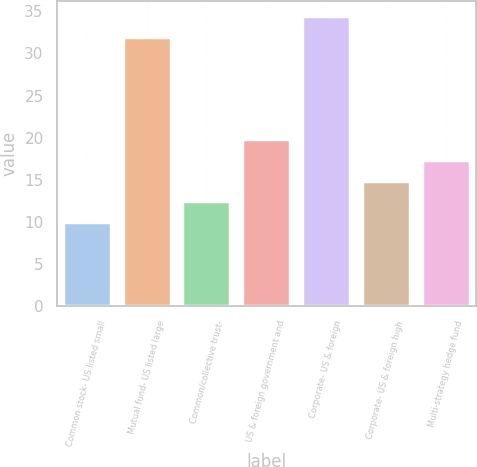<chart> <loc_0><loc_0><loc_500><loc_500><bar_chart><fcel>Common stock- US listed small<fcel>Mutual fund- US listed large<fcel>Common/collective trust-<fcel>US & foreign government and<fcel>Corporate- US & foreign<fcel>Corporate- US & foreign high<fcel>Multi-strategy hedge fund<nl><fcel>10<fcel>32<fcel>12.45<fcel>19.8<fcel>34.5<fcel>14.9<fcel>17.35<nl></chart> 